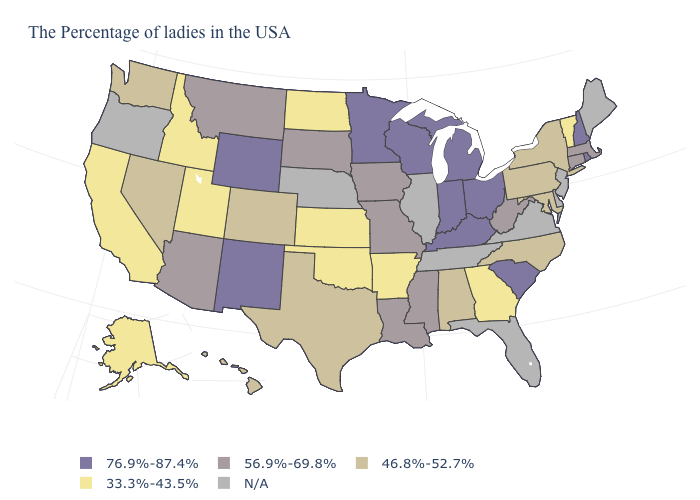Name the states that have a value in the range N/A?
Answer briefly. Maine, New Jersey, Delaware, Virginia, Florida, Tennessee, Illinois, Nebraska, Oregon. What is the value of Arizona?
Quick response, please. 56.9%-69.8%. What is the value of Kentucky?
Keep it brief. 76.9%-87.4%. Name the states that have a value in the range 46.8%-52.7%?
Quick response, please. New York, Maryland, Pennsylvania, North Carolina, Alabama, Texas, Colorado, Nevada, Washington, Hawaii. What is the lowest value in the West?
Answer briefly. 33.3%-43.5%. What is the lowest value in the South?
Keep it brief. 33.3%-43.5%. Name the states that have a value in the range 56.9%-69.8%?
Concise answer only. Massachusetts, Connecticut, West Virginia, Mississippi, Louisiana, Missouri, Iowa, South Dakota, Montana, Arizona. Name the states that have a value in the range 46.8%-52.7%?
Short answer required. New York, Maryland, Pennsylvania, North Carolina, Alabama, Texas, Colorado, Nevada, Washington, Hawaii. Which states have the lowest value in the USA?
Quick response, please. Vermont, Georgia, Arkansas, Kansas, Oklahoma, North Dakota, Utah, Idaho, California, Alaska. Name the states that have a value in the range N/A?
Answer briefly. Maine, New Jersey, Delaware, Virginia, Florida, Tennessee, Illinois, Nebraska, Oregon. What is the value of Oregon?
Answer briefly. N/A. What is the value of Virginia?
Concise answer only. N/A. Name the states that have a value in the range 76.9%-87.4%?
Concise answer only. Rhode Island, New Hampshire, South Carolina, Ohio, Michigan, Kentucky, Indiana, Wisconsin, Minnesota, Wyoming, New Mexico. What is the value of Alaska?
Keep it brief. 33.3%-43.5%. 